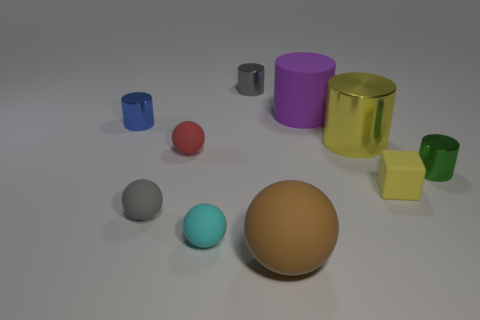What number of other objects are the same material as the small gray sphere?
Your response must be concise. 5. How many other things are there of the same color as the cube?
Your response must be concise. 1. What number of blue things are either small metallic objects or large cylinders?
Provide a short and direct response. 1. There is a gray object that is in front of the yellow thing that is in front of the green cylinder; are there any small cylinders that are on the left side of it?
Provide a succinct answer. Yes. Does the matte block have the same color as the large metallic cylinder?
Ensure brevity in your answer.  Yes. What color is the cylinder on the right side of the small matte thing right of the large brown rubber thing?
Provide a short and direct response. Green. What number of tiny things are brown objects or matte cylinders?
Provide a short and direct response. 0. There is a thing that is on the right side of the brown object and behind the big yellow metallic thing; what is its color?
Offer a terse response. Purple. Do the large purple cylinder and the small cyan object have the same material?
Your answer should be very brief. Yes. What is the shape of the purple matte thing?
Make the answer very short. Cylinder. 